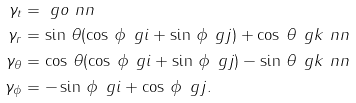Convert formula to latex. <formula><loc_0><loc_0><loc_500><loc_500>\gamma _ { t } & = \ g o \ n n \\ \gamma _ { r } & = \sin \, \theta ( \cos \, \phi \, \ g i + \sin \, \phi \, \ g j ) + \cos \, \theta \, \ g k \ n n \\ \gamma _ { \theta } & = \cos \, \theta ( \cos \, \phi \, \ g i + \sin \, \phi \, \ g j ) - \sin \, \theta \, \ g k \ n n \\ \gamma _ { \phi } & = - \sin \, \phi \, \ g i + \cos \, \phi \, \ g j .</formula> 